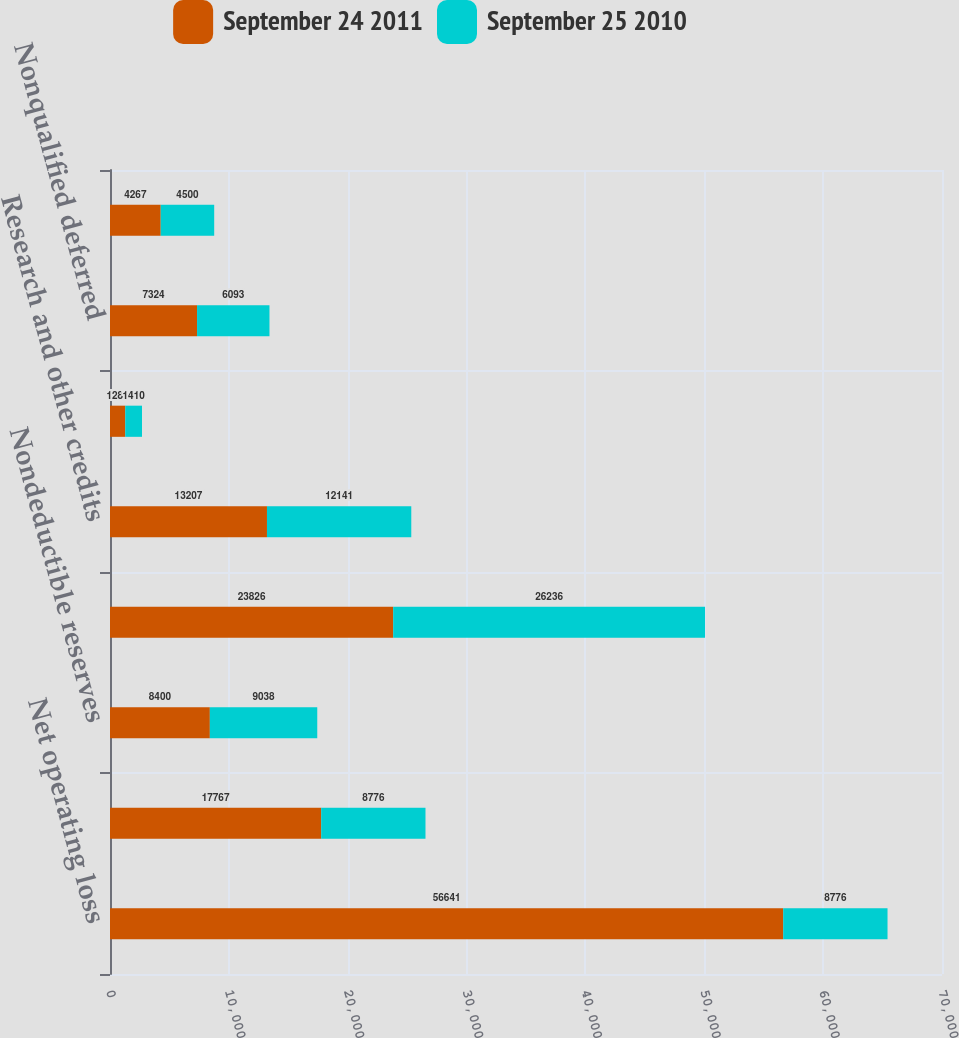Convert chart. <chart><loc_0><loc_0><loc_500><loc_500><stacked_bar_chart><ecel><fcel>Net operating loss<fcel>Nondeductible accruals<fcel>Nondeductible reserves<fcel>Stock-based compensation<fcel>Research and other credits<fcel>Convertible notes issuance<fcel>Nonqualified deferred<fcel>Other temporary differences<nl><fcel>September 24 2011<fcel>56641<fcel>17767<fcel>8400<fcel>23826<fcel>13207<fcel>1283<fcel>7324<fcel>4267<nl><fcel>September 25 2010<fcel>8776<fcel>8776<fcel>9038<fcel>26236<fcel>12141<fcel>1410<fcel>6093<fcel>4500<nl></chart> 